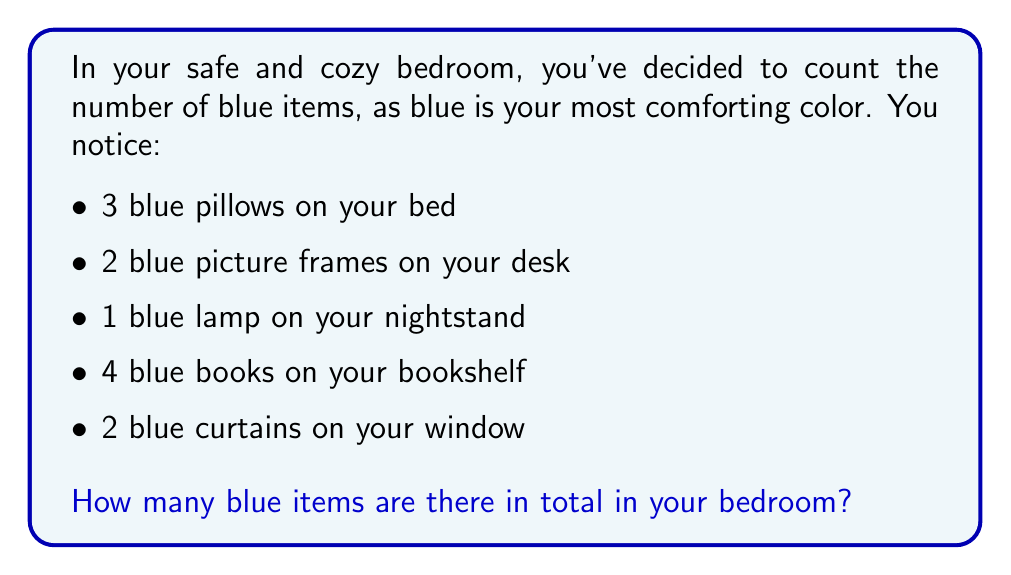Help me with this question. To find the total number of blue items in the bedroom, we need to add up all the blue items mentioned:

1. Blue pillows: 3
2. Blue picture frames: 2
3. Blue lamp: 1
4. Blue books: 4
5. Blue curtains: 2

We can represent this as a simple addition problem:

$$ 3 + 2 + 1 + 4 + 2 = 12 $$

Let's break it down step by step:

1. $3 + 2 = 5$ (pillows and picture frames)
2. $5 + 1 = 6$ (add the lamp)
3. $6 + 4 = 10$ (add the books)
4. $10 + 2 = 12$ (add the curtains)

Therefore, the total number of blue items in the bedroom is 12.
Answer: $12$ blue items 